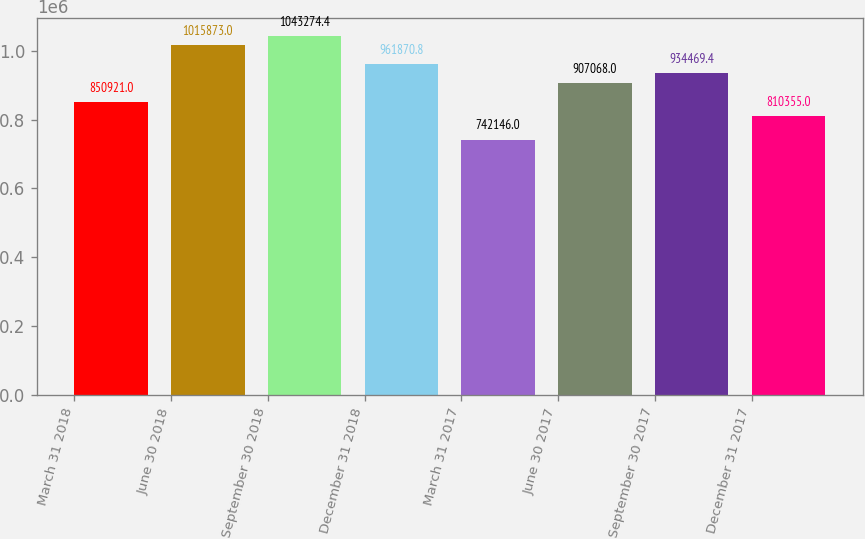Convert chart. <chart><loc_0><loc_0><loc_500><loc_500><bar_chart><fcel>March 31 2018<fcel>June 30 2018<fcel>September 30 2018<fcel>December 31 2018<fcel>March 31 2017<fcel>June 30 2017<fcel>September 30 2017<fcel>December 31 2017<nl><fcel>850921<fcel>1.01587e+06<fcel>1.04327e+06<fcel>961871<fcel>742146<fcel>907068<fcel>934469<fcel>810355<nl></chart> 